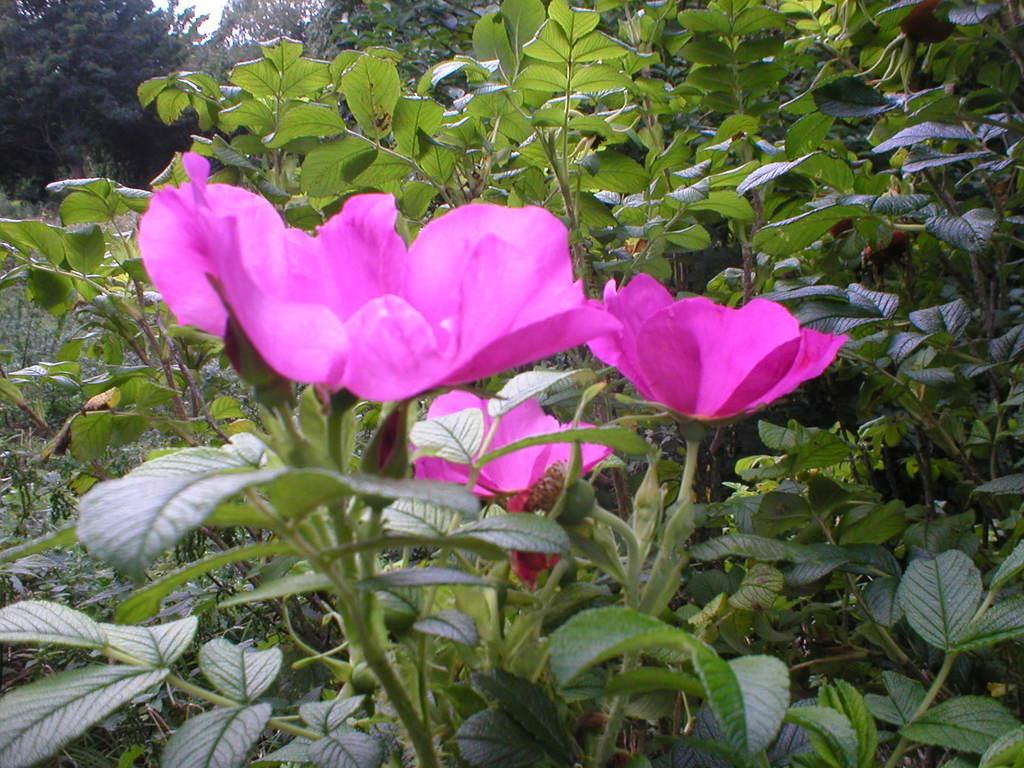How would you summarize this image in a sentence or two? In this image there are flowers on the plant behind them there are so many trees. 